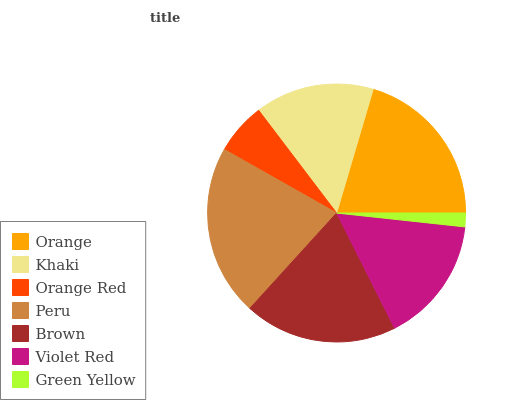Is Green Yellow the minimum?
Answer yes or no. Yes. Is Peru the maximum?
Answer yes or no. Yes. Is Khaki the minimum?
Answer yes or no. No. Is Khaki the maximum?
Answer yes or no. No. Is Orange greater than Khaki?
Answer yes or no. Yes. Is Khaki less than Orange?
Answer yes or no. Yes. Is Khaki greater than Orange?
Answer yes or no. No. Is Orange less than Khaki?
Answer yes or no. No. Is Violet Red the high median?
Answer yes or no. Yes. Is Violet Red the low median?
Answer yes or no. Yes. Is Khaki the high median?
Answer yes or no. No. Is Brown the low median?
Answer yes or no. No. 